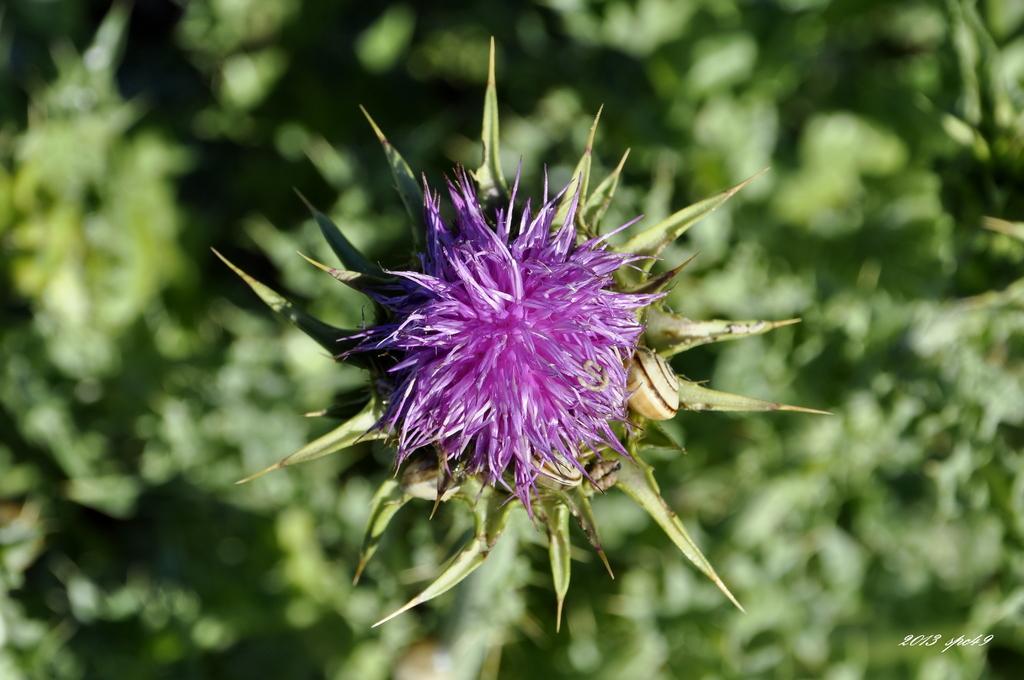How would you summarize this image in a sentence or two? In front of the image there is a flower. Around the flower there are leaves. There is some text and numbers at the bottom of the image. 